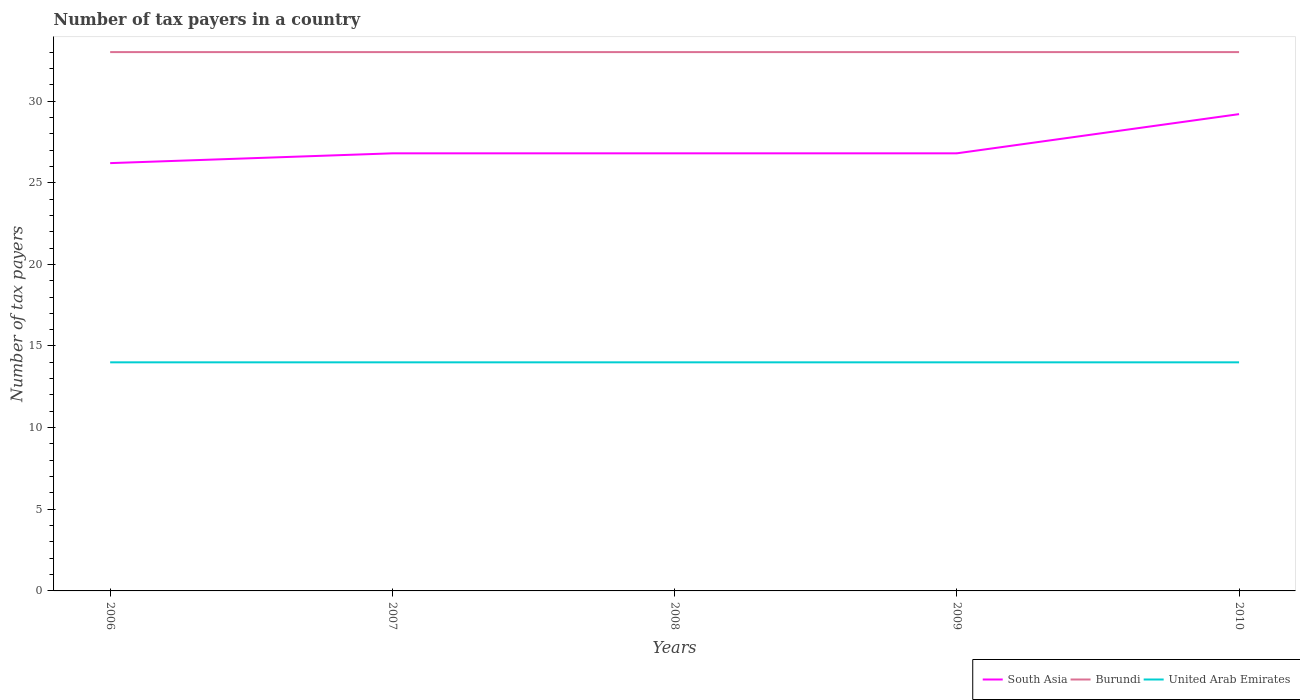How many different coloured lines are there?
Give a very brief answer. 3. Does the line corresponding to South Asia intersect with the line corresponding to United Arab Emirates?
Offer a very short reply. No. Is the number of lines equal to the number of legend labels?
Make the answer very short. Yes. Across all years, what is the maximum number of tax payers in in South Asia?
Keep it short and to the point. 26.2. What is the total number of tax payers in in South Asia in the graph?
Give a very brief answer. 0. What is the difference between the highest and the lowest number of tax payers in in United Arab Emirates?
Ensure brevity in your answer.  0. How many lines are there?
Your answer should be very brief. 3. What is the difference between two consecutive major ticks on the Y-axis?
Give a very brief answer. 5. Are the values on the major ticks of Y-axis written in scientific E-notation?
Your answer should be compact. No. How many legend labels are there?
Provide a succinct answer. 3. What is the title of the graph?
Provide a succinct answer. Number of tax payers in a country. What is the label or title of the Y-axis?
Your answer should be very brief. Number of tax payers. What is the Number of tax payers in South Asia in 2006?
Give a very brief answer. 26.2. What is the Number of tax payers of Burundi in 2006?
Make the answer very short. 33. What is the Number of tax payers of South Asia in 2007?
Ensure brevity in your answer.  26.8. What is the Number of tax payers in South Asia in 2008?
Keep it short and to the point. 26.8. What is the Number of tax payers in Burundi in 2008?
Your answer should be very brief. 33. What is the Number of tax payers in South Asia in 2009?
Your answer should be very brief. 26.8. What is the Number of tax payers in United Arab Emirates in 2009?
Offer a very short reply. 14. What is the Number of tax payers of South Asia in 2010?
Offer a terse response. 29.2. What is the Number of tax payers in Burundi in 2010?
Make the answer very short. 33. Across all years, what is the maximum Number of tax payers in South Asia?
Your answer should be compact. 29.2. Across all years, what is the maximum Number of tax payers of Burundi?
Offer a terse response. 33. Across all years, what is the maximum Number of tax payers of United Arab Emirates?
Your answer should be compact. 14. Across all years, what is the minimum Number of tax payers of South Asia?
Ensure brevity in your answer.  26.2. Across all years, what is the minimum Number of tax payers of Burundi?
Ensure brevity in your answer.  33. Across all years, what is the minimum Number of tax payers in United Arab Emirates?
Your response must be concise. 14. What is the total Number of tax payers of South Asia in the graph?
Your answer should be very brief. 135.8. What is the total Number of tax payers in Burundi in the graph?
Offer a very short reply. 165. What is the difference between the Number of tax payers of South Asia in 2006 and that in 2007?
Your response must be concise. -0.6. What is the difference between the Number of tax payers of Burundi in 2006 and that in 2007?
Provide a short and direct response. 0. What is the difference between the Number of tax payers in United Arab Emirates in 2006 and that in 2008?
Provide a short and direct response. 0. What is the difference between the Number of tax payers of South Asia in 2006 and that in 2009?
Keep it short and to the point. -0.6. What is the difference between the Number of tax payers of Burundi in 2006 and that in 2009?
Keep it short and to the point. 0. What is the difference between the Number of tax payers in South Asia in 2006 and that in 2010?
Your answer should be compact. -3. What is the difference between the Number of tax payers of Burundi in 2006 and that in 2010?
Give a very brief answer. 0. What is the difference between the Number of tax payers of United Arab Emirates in 2006 and that in 2010?
Your answer should be very brief. 0. What is the difference between the Number of tax payers in South Asia in 2007 and that in 2008?
Your response must be concise. 0. What is the difference between the Number of tax payers in United Arab Emirates in 2007 and that in 2009?
Your answer should be compact. 0. What is the difference between the Number of tax payers of United Arab Emirates in 2007 and that in 2010?
Make the answer very short. 0. What is the difference between the Number of tax payers in South Asia in 2008 and that in 2009?
Make the answer very short. 0. What is the difference between the Number of tax payers in United Arab Emirates in 2008 and that in 2009?
Make the answer very short. 0. What is the difference between the Number of tax payers of South Asia in 2008 and that in 2010?
Your answer should be compact. -2.4. What is the difference between the Number of tax payers in United Arab Emirates in 2008 and that in 2010?
Give a very brief answer. 0. What is the difference between the Number of tax payers in South Asia in 2006 and the Number of tax payers in Burundi in 2007?
Keep it short and to the point. -6.8. What is the difference between the Number of tax payers in South Asia in 2006 and the Number of tax payers in United Arab Emirates in 2007?
Your answer should be compact. 12.2. What is the difference between the Number of tax payers of Burundi in 2006 and the Number of tax payers of United Arab Emirates in 2007?
Provide a short and direct response. 19. What is the difference between the Number of tax payers in South Asia in 2006 and the Number of tax payers in United Arab Emirates in 2008?
Offer a terse response. 12.2. What is the difference between the Number of tax payers in Burundi in 2006 and the Number of tax payers in United Arab Emirates in 2008?
Provide a succinct answer. 19. What is the difference between the Number of tax payers of South Asia in 2006 and the Number of tax payers of Burundi in 2010?
Provide a short and direct response. -6.8. What is the difference between the Number of tax payers of South Asia in 2007 and the Number of tax payers of Burundi in 2008?
Ensure brevity in your answer.  -6.2. What is the difference between the Number of tax payers of South Asia in 2007 and the Number of tax payers of United Arab Emirates in 2008?
Provide a succinct answer. 12.8. What is the difference between the Number of tax payers of Burundi in 2007 and the Number of tax payers of United Arab Emirates in 2008?
Your answer should be very brief. 19. What is the difference between the Number of tax payers of South Asia in 2007 and the Number of tax payers of Burundi in 2009?
Your response must be concise. -6.2. What is the difference between the Number of tax payers of South Asia in 2007 and the Number of tax payers of Burundi in 2010?
Your answer should be very brief. -6.2. What is the difference between the Number of tax payers in Burundi in 2007 and the Number of tax payers in United Arab Emirates in 2010?
Your answer should be compact. 19. What is the difference between the Number of tax payers of South Asia in 2008 and the Number of tax payers of United Arab Emirates in 2009?
Make the answer very short. 12.8. What is the difference between the Number of tax payers of Burundi in 2008 and the Number of tax payers of United Arab Emirates in 2009?
Your answer should be very brief. 19. What is the difference between the Number of tax payers in South Asia in 2008 and the Number of tax payers in Burundi in 2010?
Your answer should be very brief. -6.2. What is the difference between the Number of tax payers of South Asia in 2008 and the Number of tax payers of United Arab Emirates in 2010?
Make the answer very short. 12.8. What is the difference between the Number of tax payers in Burundi in 2009 and the Number of tax payers in United Arab Emirates in 2010?
Offer a terse response. 19. What is the average Number of tax payers of South Asia per year?
Provide a succinct answer. 27.16. What is the average Number of tax payers of Burundi per year?
Your response must be concise. 33. What is the average Number of tax payers in United Arab Emirates per year?
Your answer should be compact. 14. In the year 2006, what is the difference between the Number of tax payers of South Asia and Number of tax payers of Burundi?
Offer a very short reply. -6.8. In the year 2006, what is the difference between the Number of tax payers in Burundi and Number of tax payers in United Arab Emirates?
Your response must be concise. 19. In the year 2008, what is the difference between the Number of tax payers of South Asia and Number of tax payers of Burundi?
Provide a short and direct response. -6.2. In the year 2010, what is the difference between the Number of tax payers of South Asia and Number of tax payers of Burundi?
Offer a terse response. -3.8. What is the ratio of the Number of tax payers of South Asia in 2006 to that in 2007?
Provide a short and direct response. 0.98. What is the ratio of the Number of tax payers in Burundi in 2006 to that in 2007?
Provide a short and direct response. 1. What is the ratio of the Number of tax payers of South Asia in 2006 to that in 2008?
Keep it short and to the point. 0.98. What is the ratio of the Number of tax payers of Burundi in 2006 to that in 2008?
Ensure brevity in your answer.  1. What is the ratio of the Number of tax payers in United Arab Emirates in 2006 to that in 2008?
Your response must be concise. 1. What is the ratio of the Number of tax payers in South Asia in 2006 to that in 2009?
Keep it short and to the point. 0.98. What is the ratio of the Number of tax payers of South Asia in 2006 to that in 2010?
Keep it short and to the point. 0.9. What is the ratio of the Number of tax payers of Burundi in 2006 to that in 2010?
Provide a short and direct response. 1. What is the ratio of the Number of tax payers of United Arab Emirates in 2007 to that in 2008?
Offer a very short reply. 1. What is the ratio of the Number of tax payers in South Asia in 2007 to that in 2009?
Provide a succinct answer. 1. What is the ratio of the Number of tax payers of Burundi in 2007 to that in 2009?
Give a very brief answer. 1. What is the ratio of the Number of tax payers in United Arab Emirates in 2007 to that in 2009?
Ensure brevity in your answer.  1. What is the ratio of the Number of tax payers of South Asia in 2007 to that in 2010?
Make the answer very short. 0.92. What is the ratio of the Number of tax payers in South Asia in 2008 to that in 2009?
Your answer should be very brief. 1. What is the ratio of the Number of tax payers in United Arab Emirates in 2008 to that in 2009?
Make the answer very short. 1. What is the ratio of the Number of tax payers of South Asia in 2008 to that in 2010?
Offer a very short reply. 0.92. What is the ratio of the Number of tax payers of South Asia in 2009 to that in 2010?
Your response must be concise. 0.92. What is the difference between the highest and the second highest Number of tax payers of Burundi?
Your response must be concise. 0. What is the difference between the highest and the lowest Number of tax payers in South Asia?
Give a very brief answer. 3. What is the difference between the highest and the lowest Number of tax payers of Burundi?
Ensure brevity in your answer.  0. 